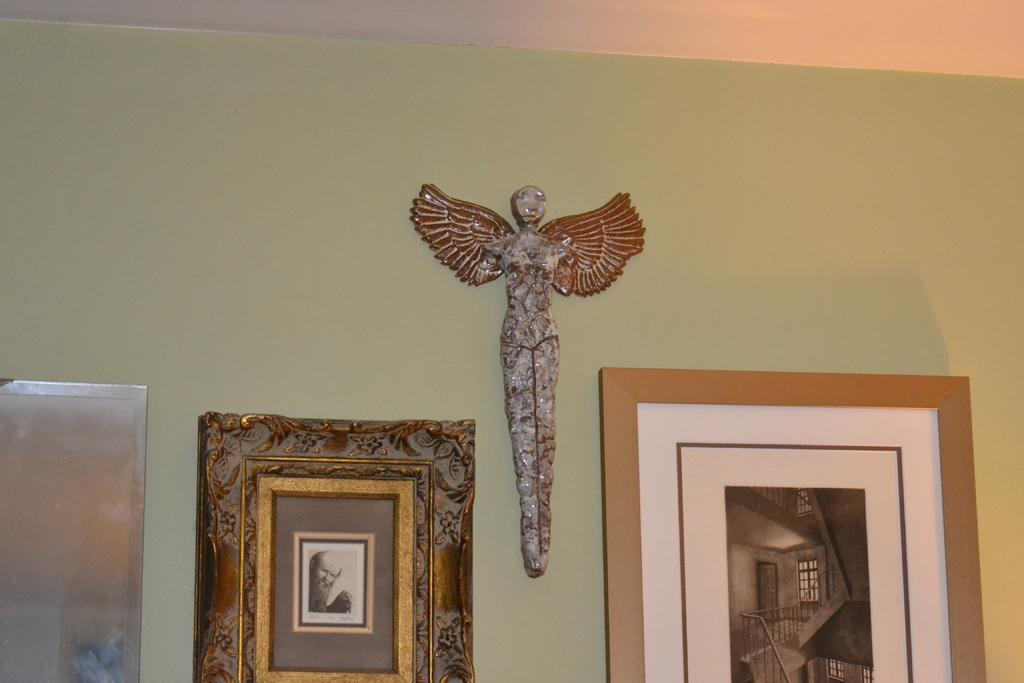What objects are present in the image that are used for displaying photos? There are photo frames in the image. What type of object can be seen on the wall in the image? There is a statue on the wall in the image. What material is used for the frame on the left side of the image? There appears to be a metal frame on the left side of the image. Can you see any rats in the image? There are no rats present in the image. What type of paper is used for the statue's base in the image? There is no paper mentioned or visible in the image; the statue is on the wall. 